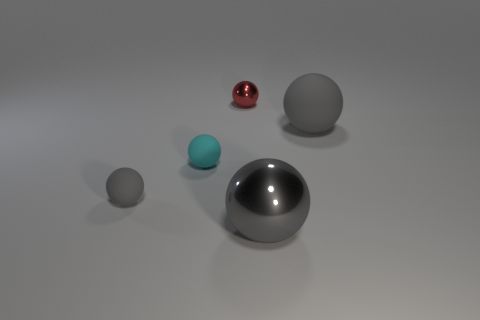What is the color of the shiny object that is in front of the metallic sphere that is behind the large gray rubber object?
Keep it short and to the point. Gray. There is another matte thing that is the same size as the cyan object; what color is it?
Your answer should be very brief. Gray. Are there any other small objects that have the same shape as the gray metal thing?
Offer a terse response. Yes. What is the shape of the large gray rubber thing?
Give a very brief answer. Sphere. Is the number of large gray metal things behind the large metallic thing greater than the number of gray rubber things that are to the right of the small cyan ball?
Your response must be concise. No. How many other objects are there of the same size as the cyan rubber ball?
Make the answer very short. 2. There is a gray sphere that is in front of the tiny cyan thing and right of the red shiny ball; what material is it?
Your answer should be compact. Metal. There is another small cyan thing that is the same shape as the small shiny thing; what material is it?
Your response must be concise. Rubber. How many tiny red balls are behind the shiny thing that is in front of the big gray ball that is on the right side of the gray shiny ball?
Your answer should be compact. 1. Are there any other things that have the same color as the tiny metal object?
Give a very brief answer. No. 